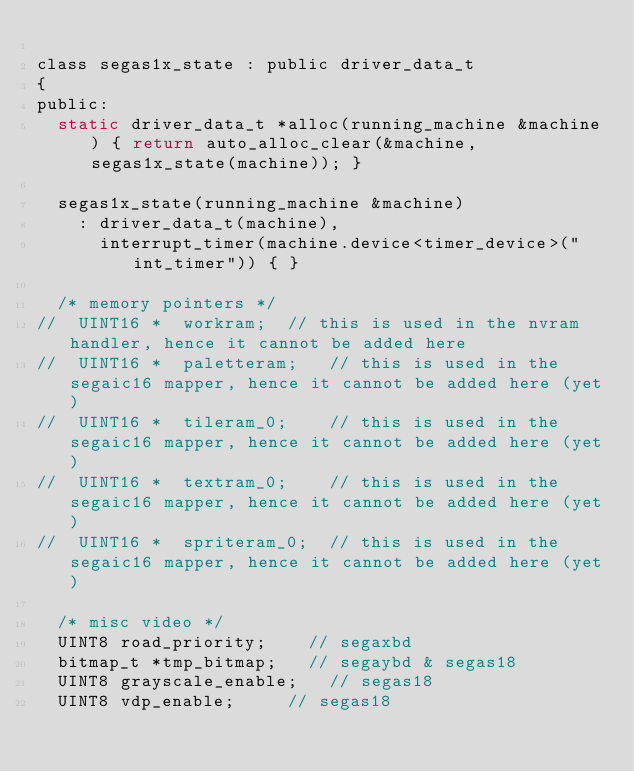<code> <loc_0><loc_0><loc_500><loc_500><_C_>
class segas1x_state : public driver_data_t
{
public:
	static driver_data_t *alloc(running_machine &machine) { return auto_alloc_clear(&machine, segas1x_state(machine)); }

	segas1x_state(running_machine &machine)
		: driver_data_t(machine),
		  interrupt_timer(machine.device<timer_device>("int_timer")) { }

	/* memory pointers */
//  UINT16 *  workram;  // this is used in the nvram handler, hence it cannot be added here
//  UINT16 *  paletteram;   // this is used in the segaic16 mapper, hence it cannot be added here (yet)
//  UINT16 *  tileram_0;    // this is used in the segaic16 mapper, hence it cannot be added here (yet)
//  UINT16 *  textram_0;    // this is used in the segaic16 mapper, hence it cannot be added here (yet)
//  UINT16 *  spriteram_0;  // this is used in the segaic16 mapper, hence it cannot be added here (yet)

	/* misc video */
	UINT8 road_priority;		// segaxbd
	bitmap_t *tmp_bitmap;		// segaybd & segas18
	UINT8 grayscale_enable;		// segas18
	UINT8 vdp_enable;			// segas18</code> 